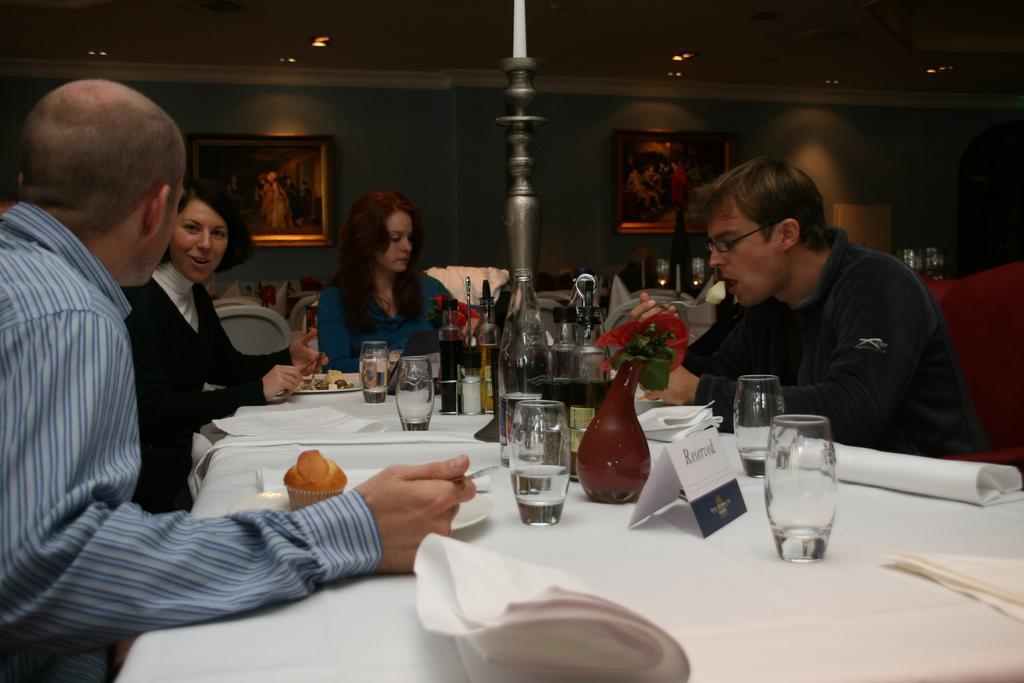Please provide a concise description of this image. In this picture we can see two woman and two men sitting on chairs and in front of them on table we have cupcakes, cloth, glass, vase with flowers in it, bottles, plate with food item, pole on table and in background we can see wall with frames. 